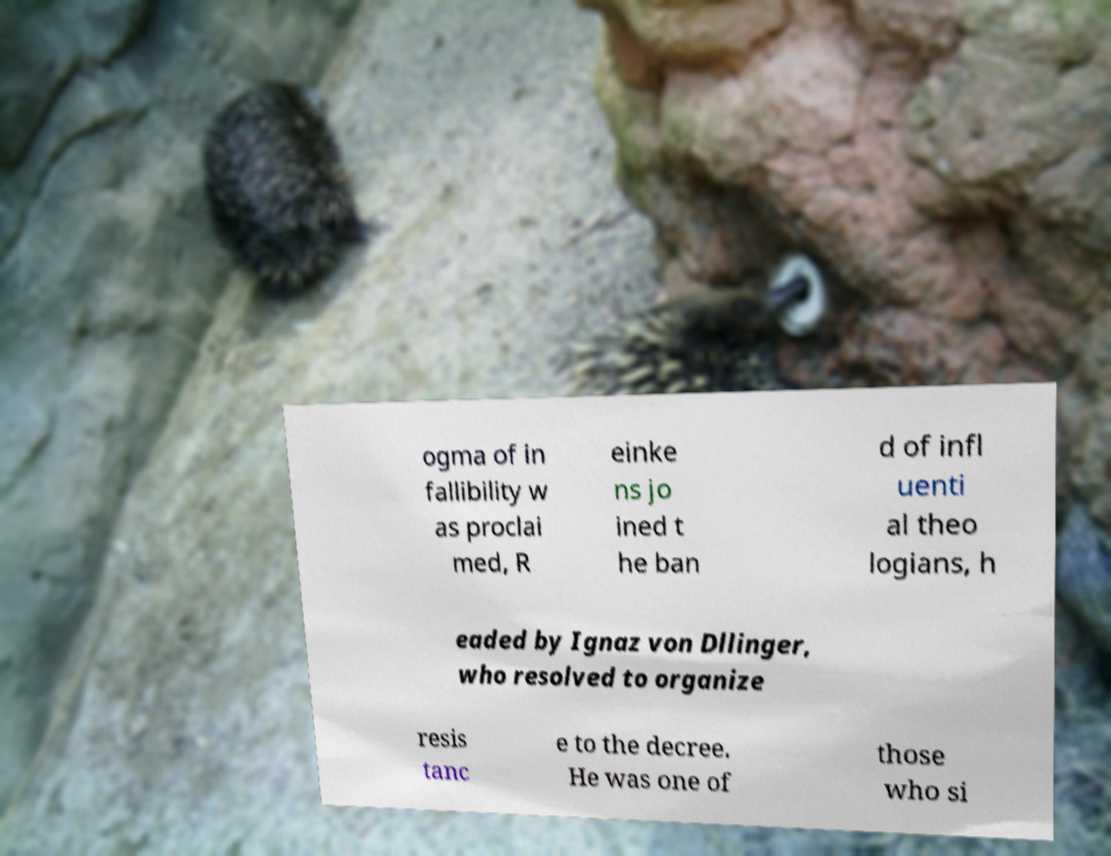For documentation purposes, I need the text within this image transcribed. Could you provide that? ogma of in fallibility w as proclai med, R einke ns jo ined t he ban d of infl uenti al theo logians, h eaded by Ignaz von Dllinger, who resolved to organize resis tanc e to the decree. He was one of those who si 